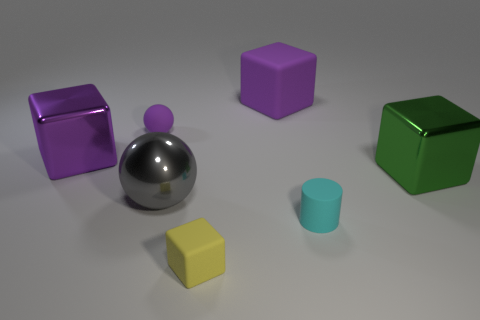Add 1 cyan matte cylinders. How many objects exist? 8 Subtract all balls. How many objects are left? 5 Add 6 large gray shiny cylinders. How many large gray shiny cylinders exist? 6 Subtract 0 gray blocks. How many objects are left? 7 Subtract all red rubber spheres. Subtract all large green blocks. How many objects are left? 6 Add 4 yellow cubes. How many yellow cubes are left? 5 